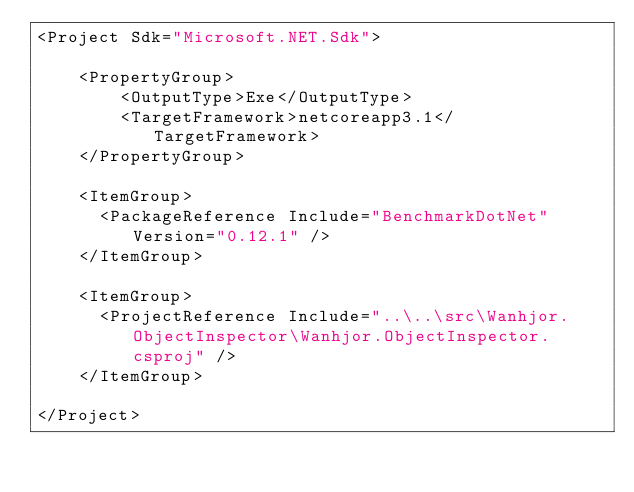<code> <loc_0><loc_0><loc_500><loc_500><_XML_><Project Sdk="Microsoft.NET.Sdk">

    <PropertyGroup>
        <OutputType>Exe</OutputType>
        <TargetFramework>netcoreapp3.1</TargetFramework>
    </PropertyGroup>

    <ItemGroup>
      <PackageReference Include="BenchmarkDotNet" Version="0.12.1" />
    </ItemGroup>

    <ItemGroup>
      <ProjectReference Include="..\..\src\Wanhjor.ObjectInspector\Wanhjor.ObjectInspector.csproj" />
    </ItemGroup>

</Project>
</code> 